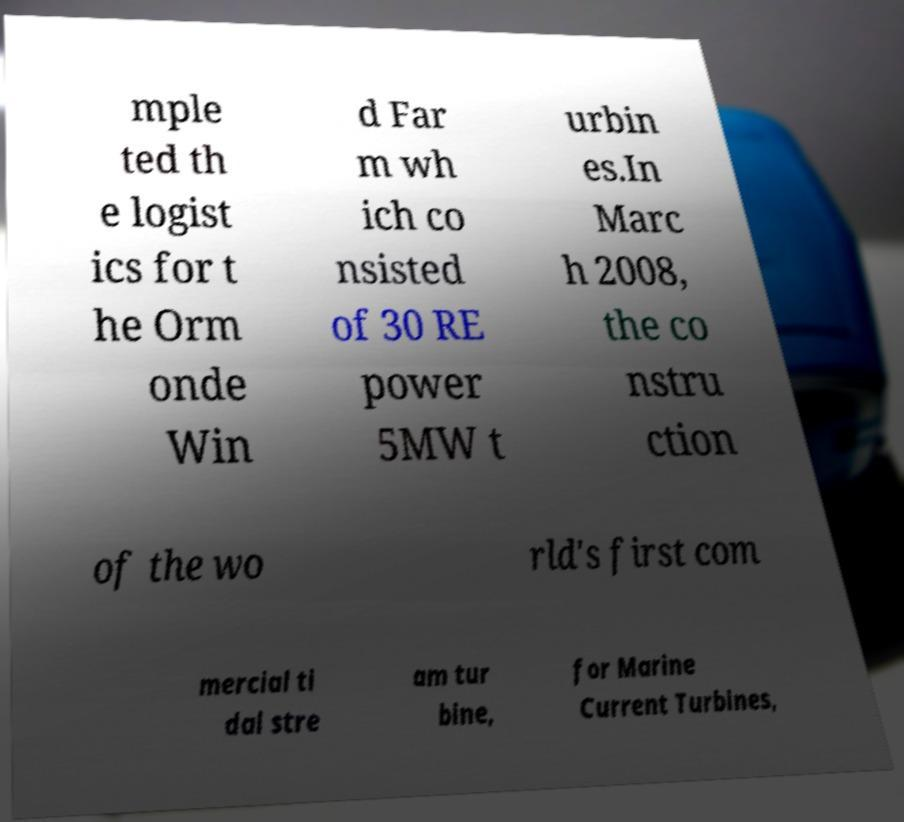Can you accurately transcribe the text from the provided image for me? mple ted th e logist ics for t he Orm onde Win d Far m wh ich co nsisted of 30 RE power 5MW t urbin es.In Marc h 2008, the co nstru ction of the wo rld's first com mercial ti dal stre am tur bine, for Marine Current Turbines, 